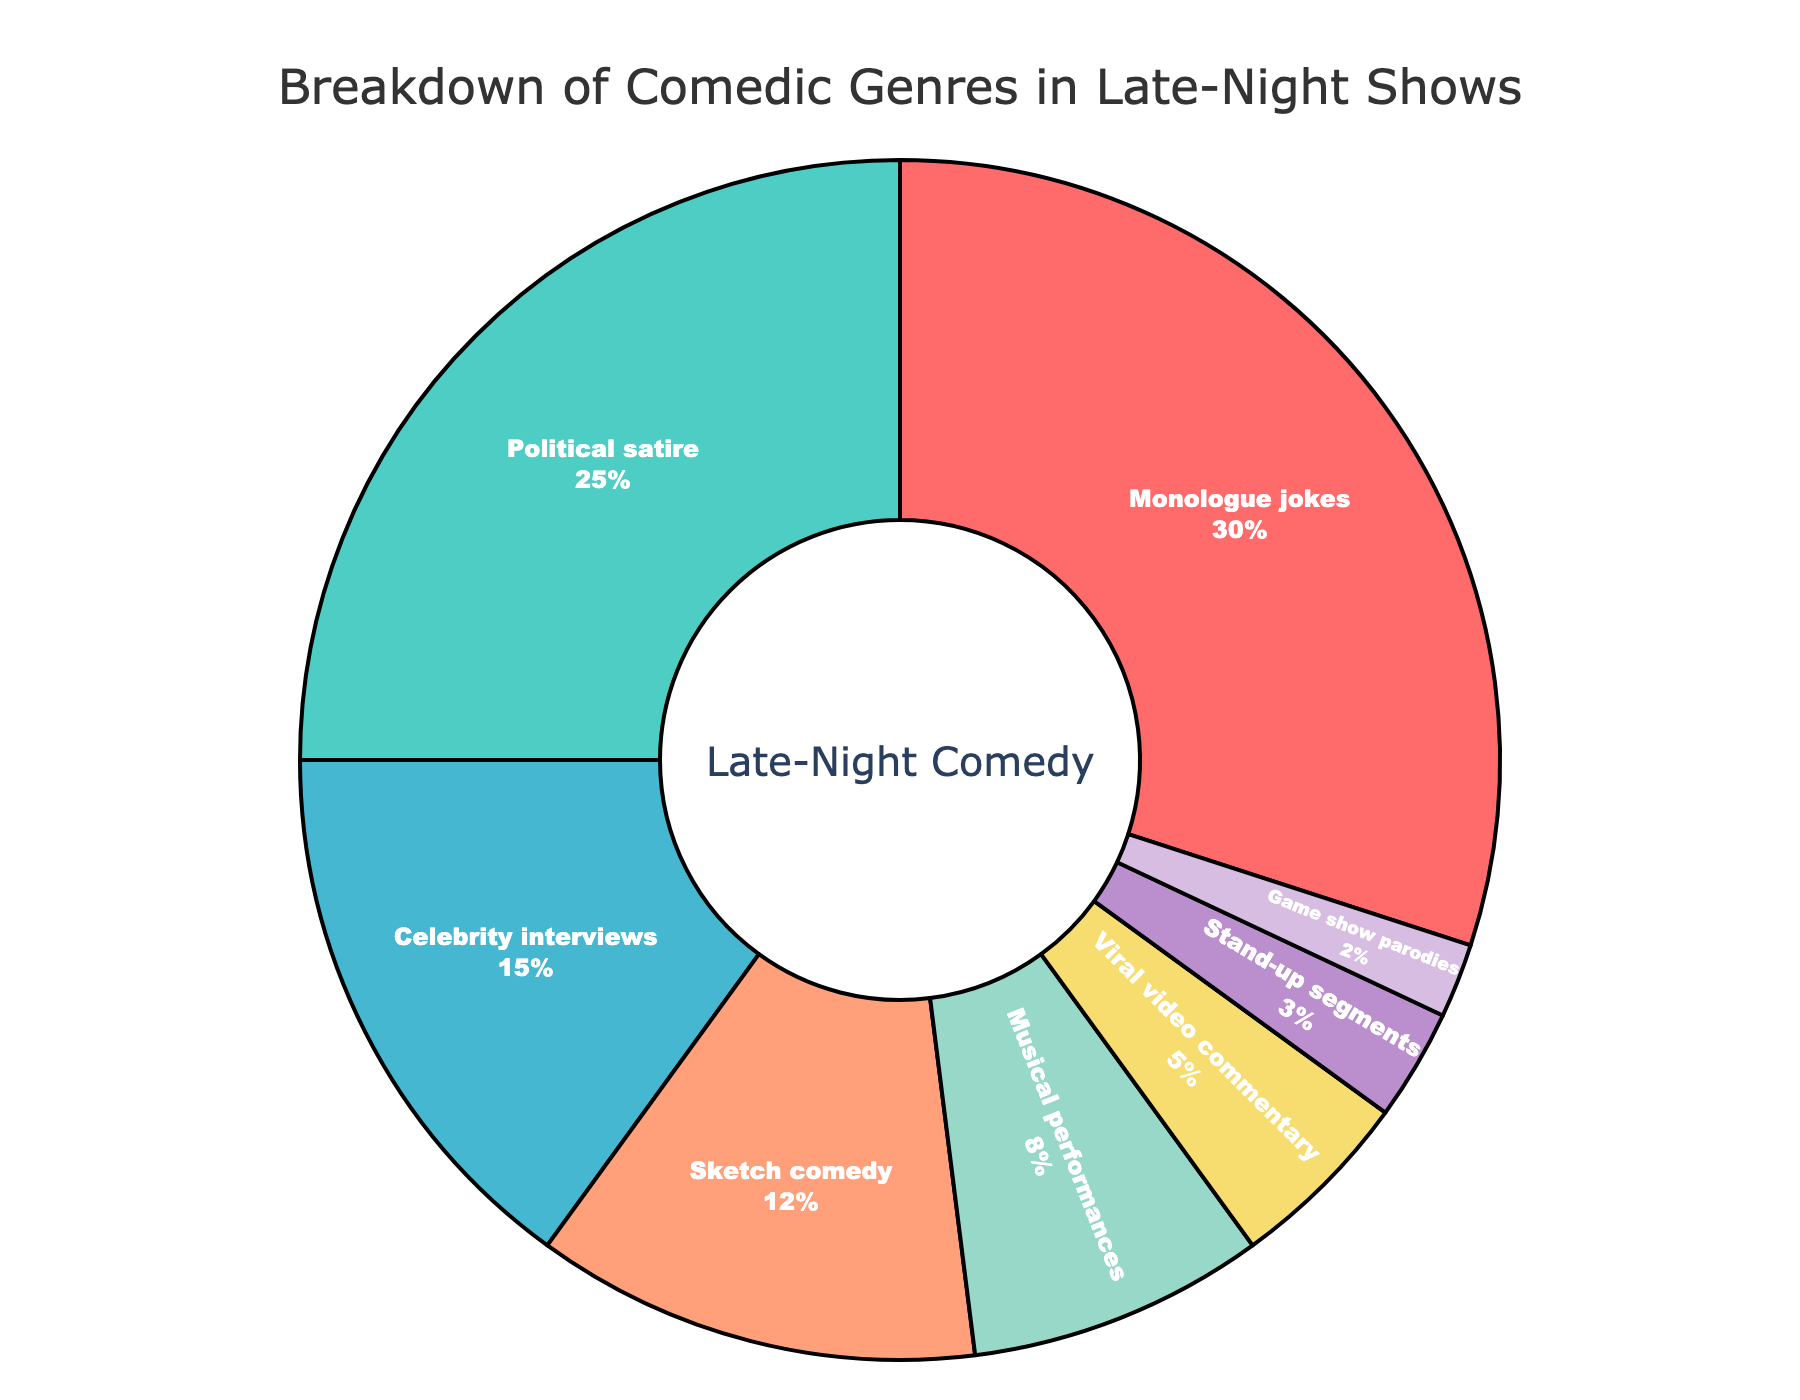What's the largest comedic genre featured in late-night shows? The largest comedic genre can be identified by the segment with the highest percentage in the pie chart. The slice for monologue jokes is the largest at 30%.
Answer: Monologue jokes Which genre has a larger percentage: Sketch comedy or Celebrity interviews? Comparing the sizes of the segments, Sketch comedy has 12%, and Celebrity interviews have 15%.
Answer: Celebrity interviews What's the combined percentage of musical performances and viral video commentary? The individual percentages for musical performances and viral video commentary are 8% and 5%, respectively. Adding these values: 8% + 5% = 13%.
Answer: 13% How much more percentage do political satire segments have compared to game show parodies? Political satire has 25%, and game show parodies have 2%. The difference is 25% - 2% = 23%.
Answer: 23% List the genres that make up less than 10% of the total. The genres with percentages less than 10% are musical performances (8%), viral video commentary (5%), stand-up segments (3%), and game show parodies (2%).
Answer: Musical performances, Viral video commentary, Stand-up segments, Game show parodies What proportion of the pie chart does the combination of stand-up segments and game show parodies represent? Stand-up segments represent 3% and game show parodies 2%. Adding these percentages: 3% + 2% = 5%.
Answer: 5% Which two genres together make up exactly the same percentage as monologue jokes alone? Monologue jokes have 30%. Political satire (25%) and stand-up segments (3%) together make 25% + 3% = 28%, which isn't exact. Similarly, combining other pairs: Celebrity interviews (15%) + Sketch comedy (12%) = 27%, not equal. However, combining Celebrity interviews (15%), Sketch comedy (12%), and Game show parodies (2%) gives 15% + 12% + 2% = 29%, which is close. No exact match found; the closest pair is Celebrity interviews and Sketch comedy plus Game show parodies.
Answer: No exact match Is political satire more popular than the combination of sketch comedy and viral video commentary? Political satire holds 25%. Sketch comedy and viral video commentary together make 12% + 5% = 17%. Since 25% > 17%, political satire is indeed more popular.
Answer: Yes Which genres occupy approximately half of the entire chart when combined? Together, monologue jokes (30%) and political satire (25%) total 55%, which is slightly more than half. The combination of monologue jokes and any other segment doesn't quite reach half.
Answer: Monologue jokes and Political satire 